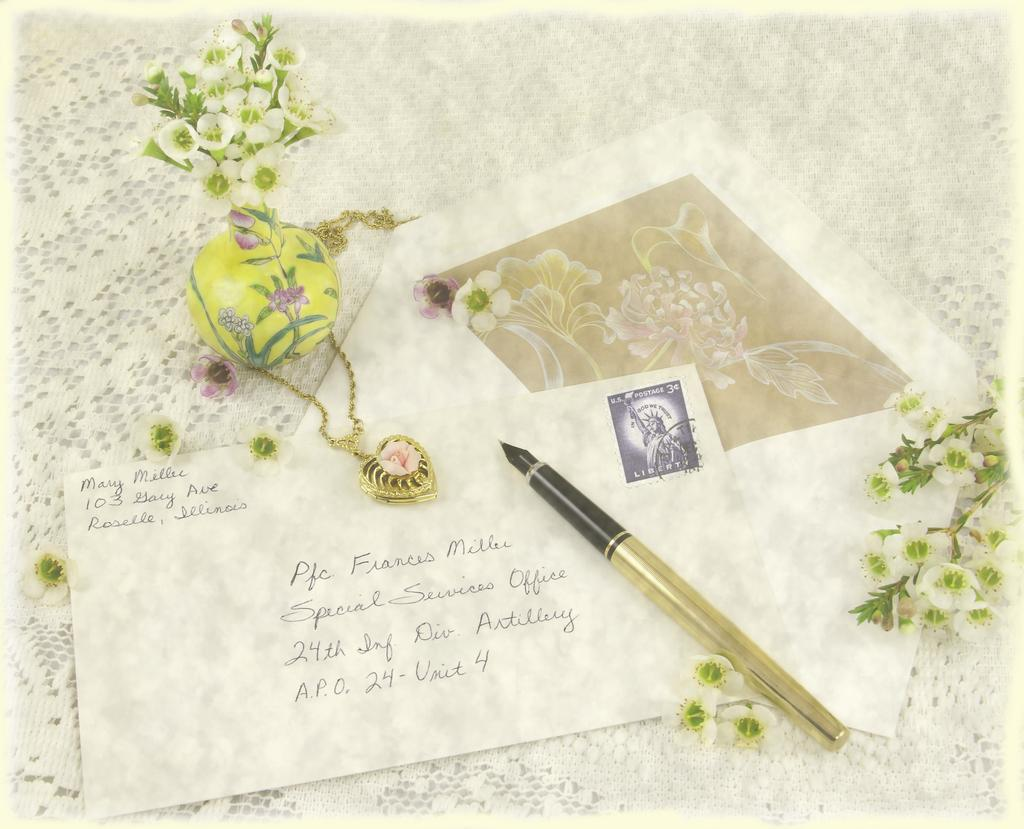Provide a one-sentence caption for the provided image. Mary is sending a card to Professor Millec. 